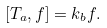<formula> <loc_0><loc_0><loc_500><loc_500>\left [ T _ { a } , f \right ] = k _ { b } f .</formula> 